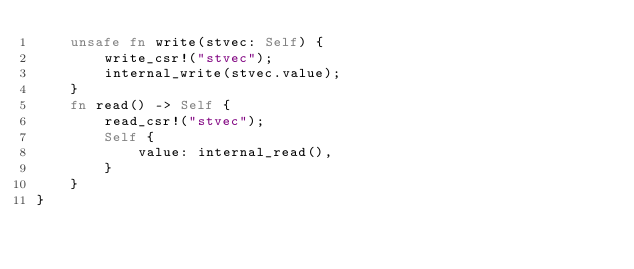<code> <loc_0><loc_0><loc_500><loc_500><_Rust_>    unsafe fn write(stvec: Self) {
        write_csr!("stvec");
        internal_write(stvec.value);
    }
    fn read() -> Self {
        read_csr!("stvec");
        Self {
            value: internal_read(),
        }
    }
}
</code> 